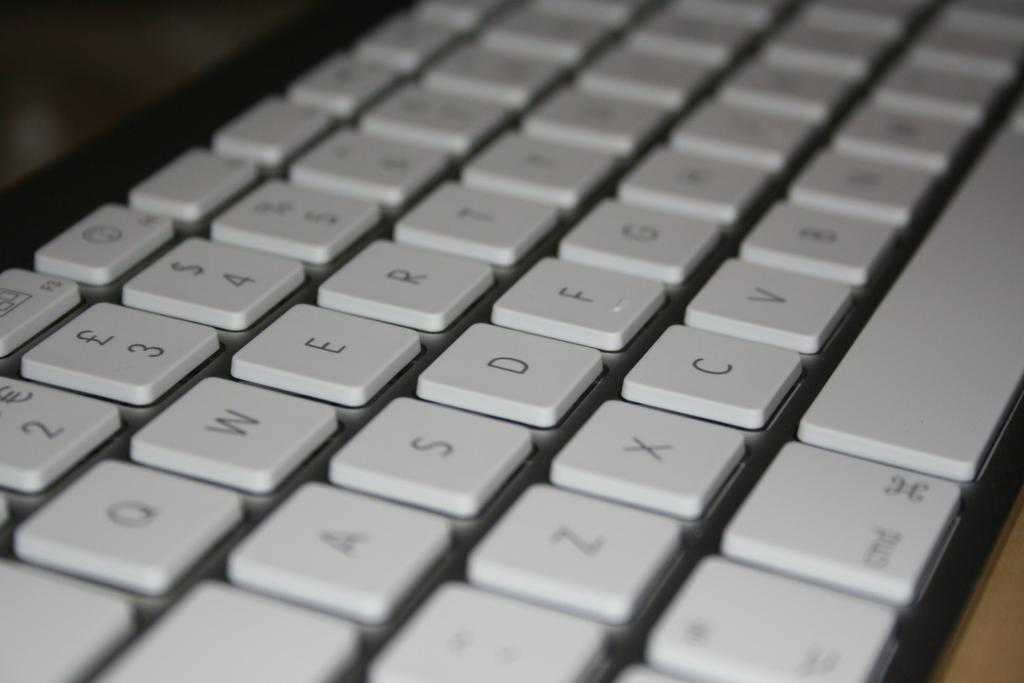What musical instrument is visible in the image? There is a keyboard in the image. Where is the keyboard located? The keyboard is placed on a table. What is the aftermath of the low store in the image? There is no reference to an aftermath, low store, or any store in the image. The image only features a keyboard placed on a table. 